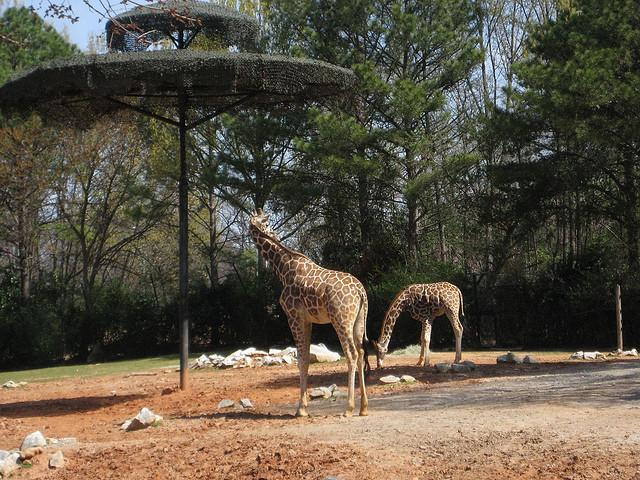What is the umbrella topped structure on the right supposed to resemble?

Choices:
A) traffic light
B) bush
C) lamp
D) tree tree 